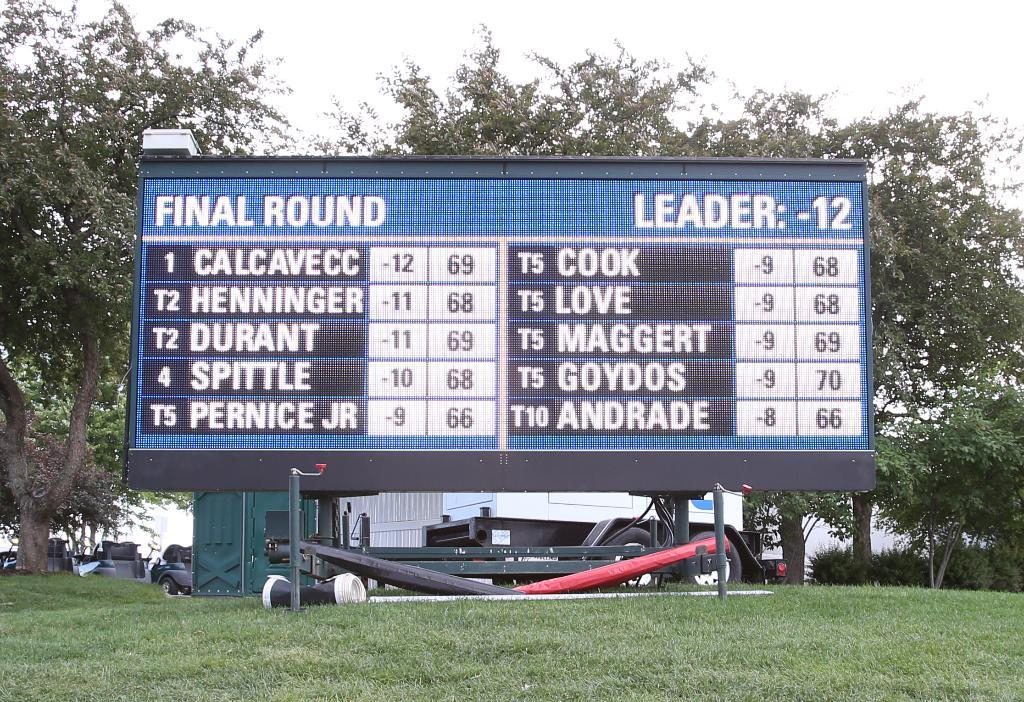<image>
Relay a brief, clear account of the picture shown. a scoreboard that says 'final round leader:-12' on it 